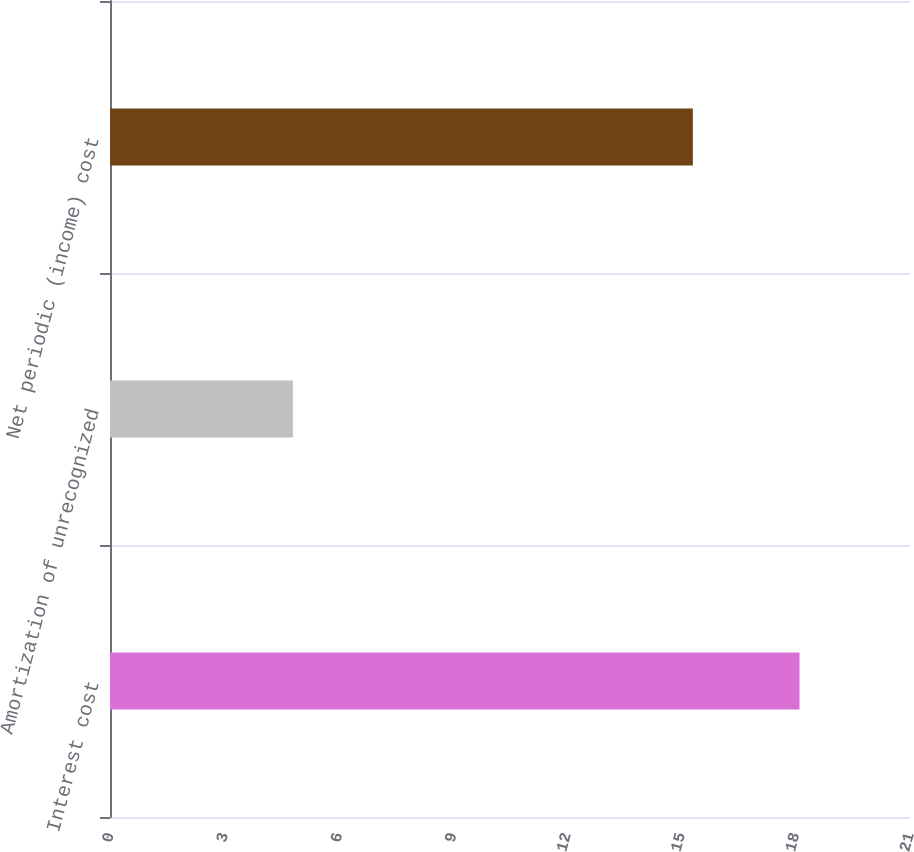<chart> <loc_0><loc_0><loc_500><loc_500><bar_chart><fcel>Interest cost<fcel>Amortization of unrecognized<fcel>Net periodic (income) cost<nl><fcel>18.1<fcel>4.8<fcel>15.3<nl></chart> 